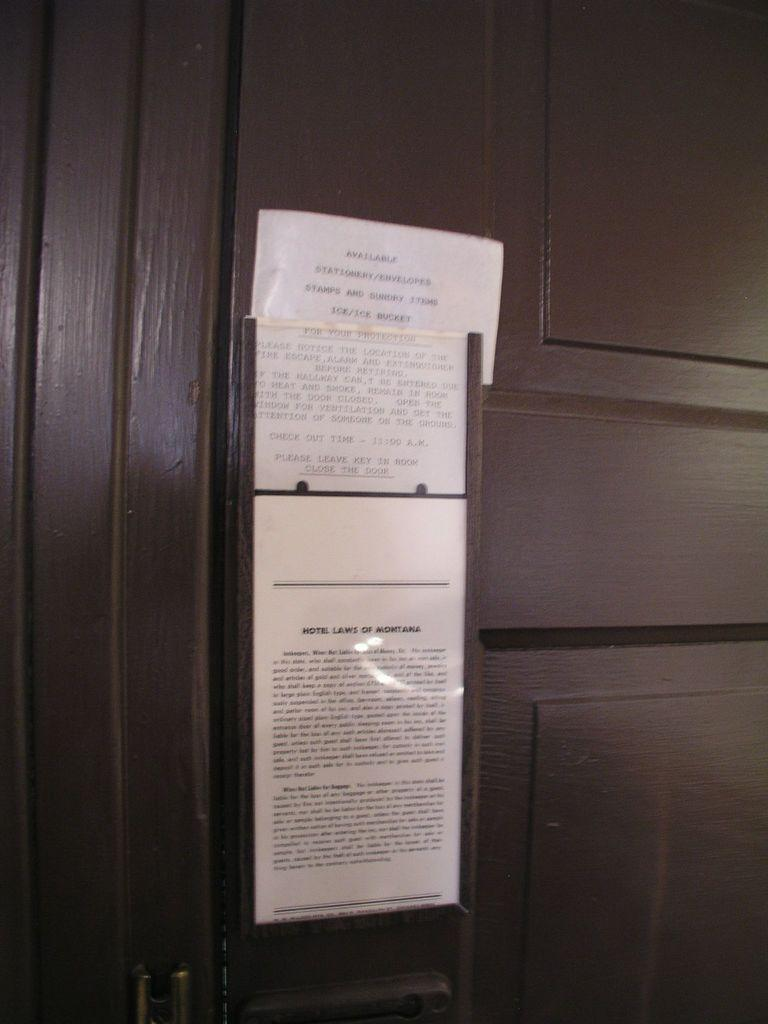<image>
Relay a brief, clear account of the picture shown. A notice that is too far away to read is posted on a dark wooden door. 